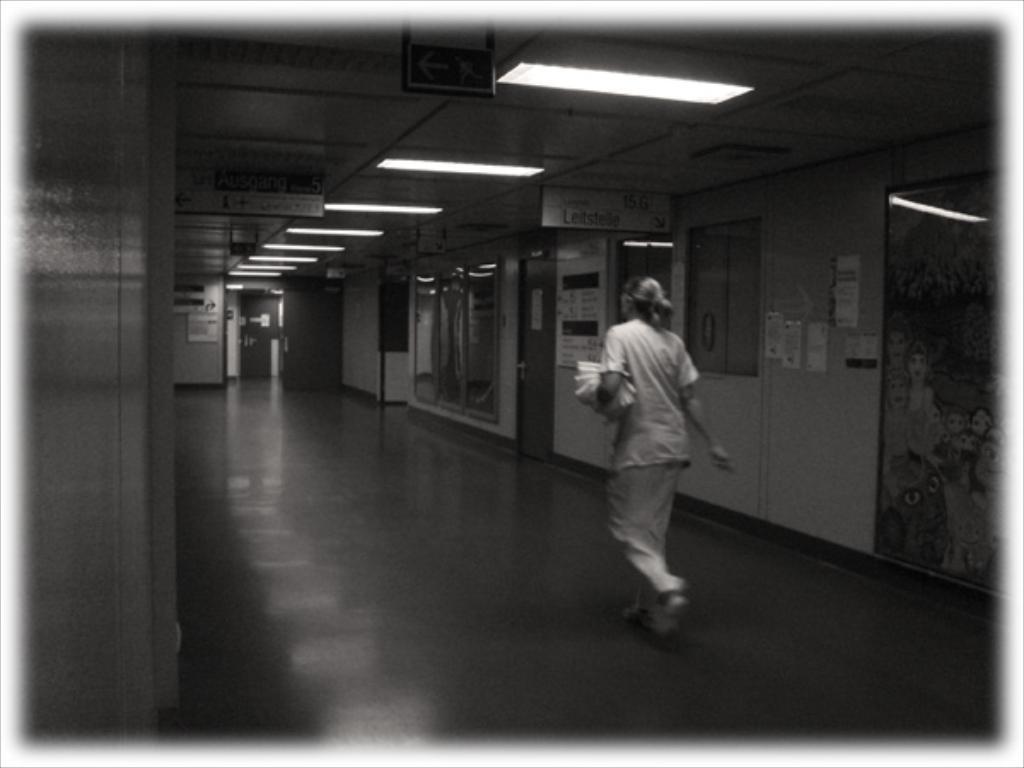How would you summarize this image in a sentence or two? In this picture I can see there is a woman walking, she is holding a few objects in her hand, there are lights attached to the ceiling, there are doors, photo frames at the right side. I can also see there are a few boards attached to the ceiling. 